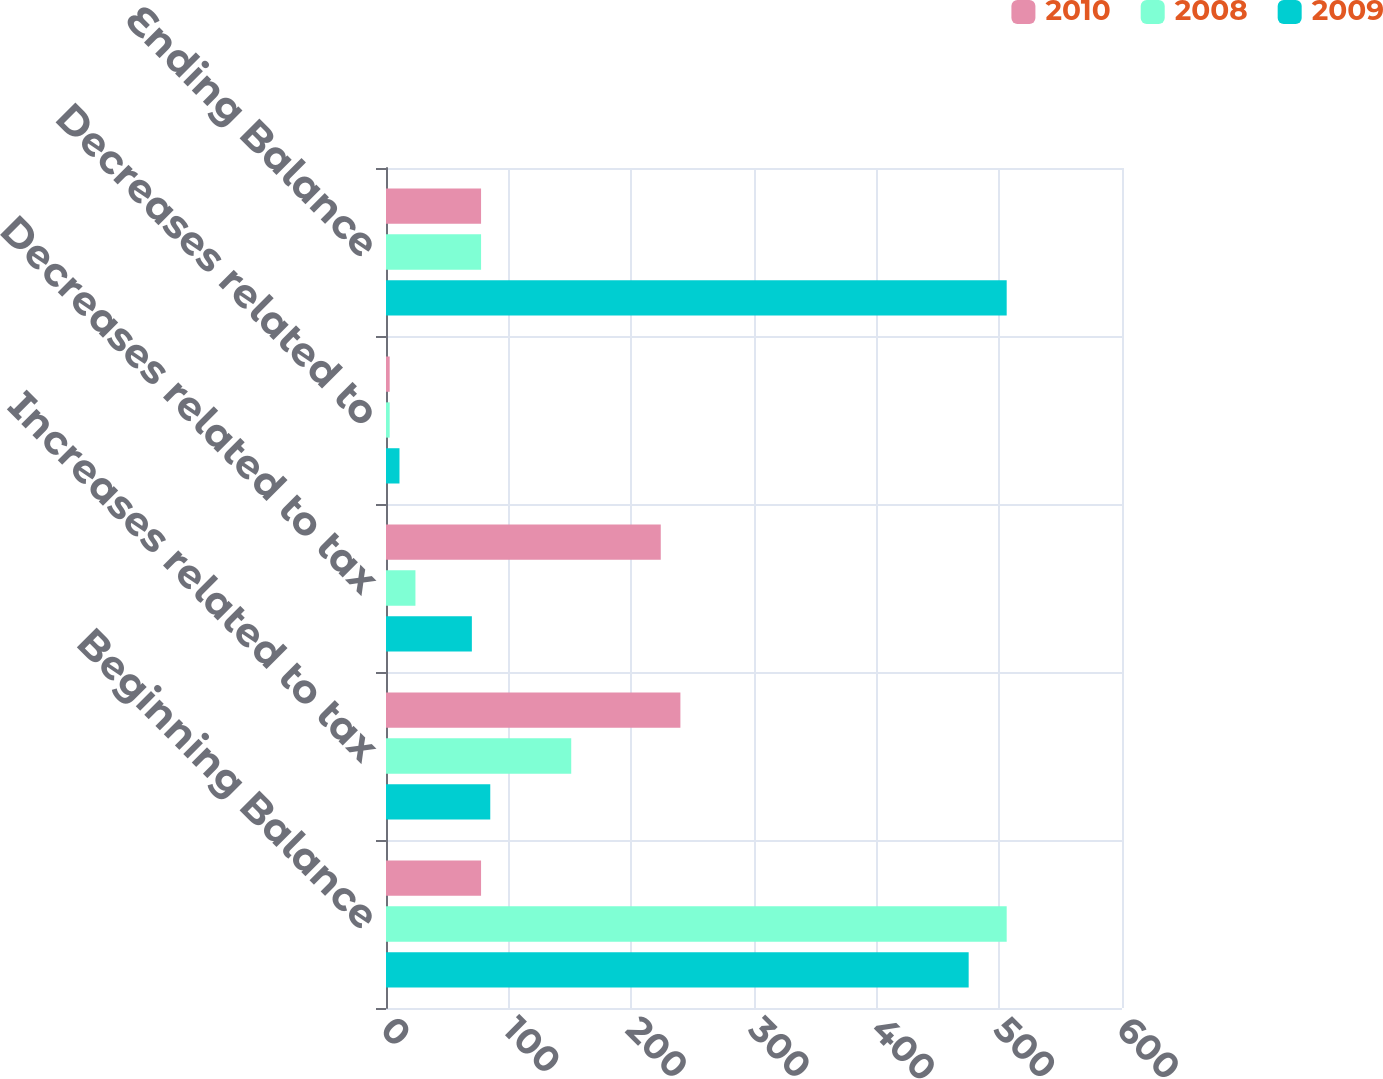Convert chart to OTSL. <chart><loc_0><loc_0><loc_500><loc_500><stacked_bar_chart><ecel><fcel>Beginning Balance<fcel>Increases related to tax<fcel>Decreases related to tax<fcel>Decreases related to<fcel>Ending Balance<nl><fcel>2010<fcel>77.5<fcel>240<fcel>224<fcel>3<fcel>77.5<nl><fcel>2008<fcel>506<fcel>151<fcel>24<fcel>3<fcel>77.5<nl><fcel>2009<fcel>475<fcel>85<fcel>70<fcel>11<fcel>506<nl></chart> 